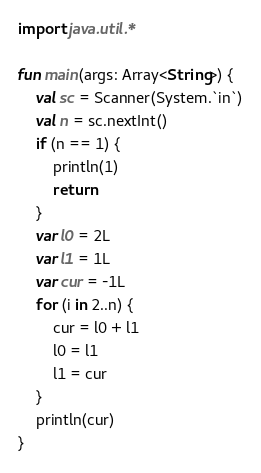<code> <loc_0><loc_0><loc_500><loc_500><_Kotlin_>import java.util.*

fun main(args: Array<String>) {
    val sc = Scanner(System.`in`)
    val n = sc.nextInt()
    if (n == 1) {
        println(1)
        return
    }
    var l0 = 2L
    var l1 = 1L
    var cur = -1L
    for (i in 2..n) {
        cur = l0 + l1
        l0 = l1
        l1 = cur
    }
    println(cur)
}</code> 